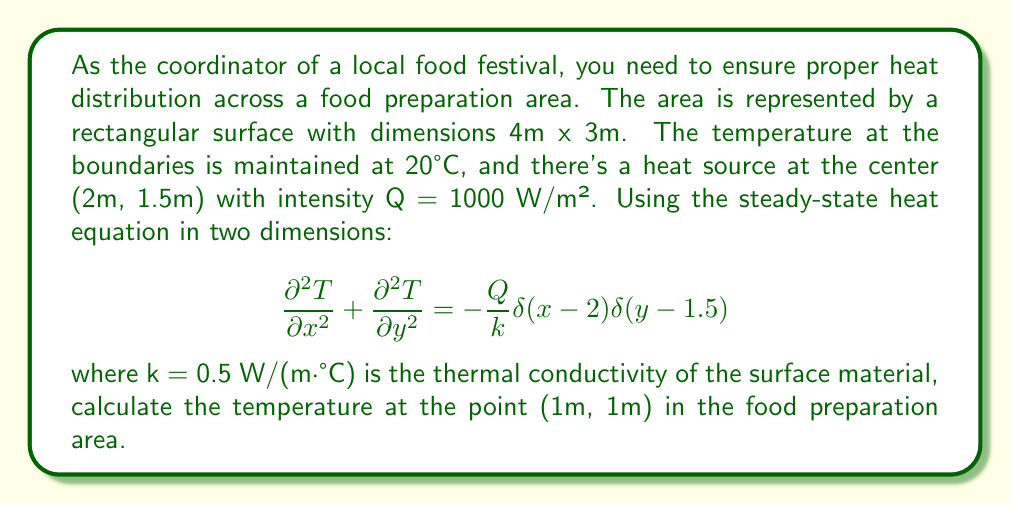Could you help me with this problem? To solve this problem, we'll use the Green's function method for the 2D heat equation with Dirichlet boundary conditions. The steps are as follows:

1) The Green's function for this problem is:

   $$G(x,y,x',y') = \frac{4}{ab}\sum_{m=1}^{\infty}\sum_{n=1}^{\infty}\frac{\sin(\frac{m\pi x}{a})\sin(\frac{n\pi y}{b})\sin(\frac{m\pi x'}{a})\sin(\frac{n\pi y'}{b})}{((\frac{m\pi}{a})^2 + (\frac{n\pi}{b})^2)}$$

   where a = 4m and b = 3m are the dimensions of the rectangle.

2) The temperature distribution is given by:

   $$T(x,y) = T_0 + \frac{Q}{k}\int_0^a\int_0^b G(x,y,x',y')\delta(x'-2)\delta(y'-1.5)dx'dy'$$

   where T_0 = 20°C is the boundary temperature.

3) Evaluating the integral with the delta functions:

   $$T(x,y) = 20 + \frac{1000}{0.5}\cdot\frac{4}{4\cdot3}\sum_{m=1}^{\infty}\sum_{n=1}^{\infty}\frac{\sin(\frac{m\pi x}{4})\sin(\frac{n\pi y}{3})\sin(\frac{m\pi \cdot 2}{4})\sin(\frac{n\pi \cdot 1.5}{3})}{((\frac{m\pi}{4})^2 + (\frac{n\pi}{3})^2)}$$

4) For the point (1m, 1m), we have:

   $$T(1,1) = 20 + 2000\cdot\frac{1}{3}\sum_{m=1}^{\infty}\sum_{n=1}^{\infty}\frac{\sin(\frac{m\pi}{4})\sin(\frac{n\pi}{3})\sin(\frac{m\pi}{2})\sin(\frac{n\pi}{2})}{((\frac{m\pi}{4})^2 + (\frac{n\pi}{3})^2)}$$

5) This double series converges rapidly. Using numerical methods to sum the first 100 terms for each series:

   $$T(1,1) \approx 20 + 2000 \cdot 0.0891 = 198.2°C$$
Answer: 198.2°C 